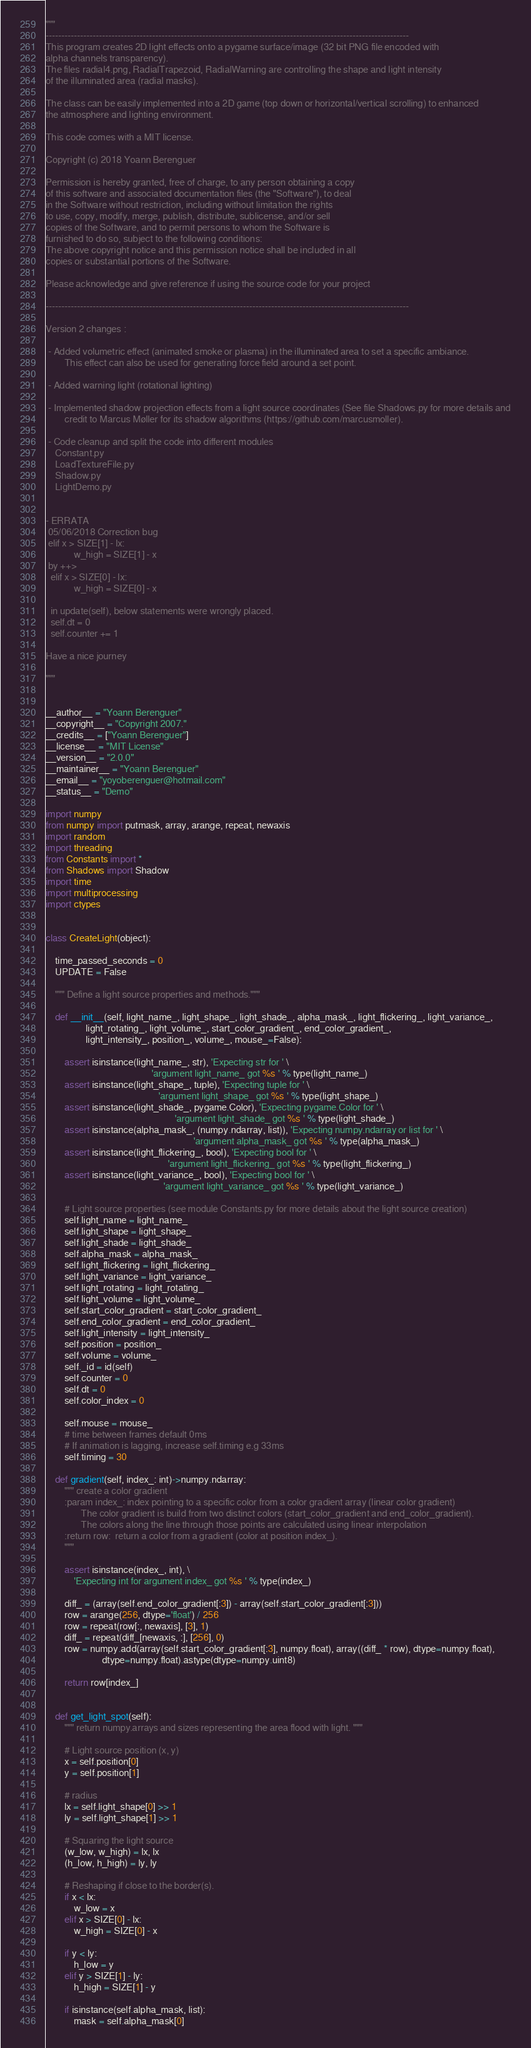<code> <loc_0><loc_0><loc_500><loc_500><_Cython_>"""
--------------------------------------------------------------------------------------------------------------------
This program creates 2D light effects onto a pygame surface/image (32 bit PNG file encoded with
alpha channels transparency).
The files radial4.png, RadialTrapezoid, RadialWarning are controlling the shape and light intensity
of the illuminated area (radial masks).

The class can be easily implemented into a 2D game (top down or horizontal/vertical scrolling) to enhanced
the atmosphere and lighting environment.

This code comes with a MIT license.

Copyright (c) 2018 Yoann Berenguer

Permission is hereby granted, free of charge, to any person obtaining a copy
of this software and associated documentation files (the "Software"), to deal
in the Software without restriction, including without limitation the rights
to use, copy, modify, merge, publish, distribute, sublicense, and/or sell
copies of the Software, and to permit persons to whom the Software is
furnished to do so, subject to the following conditions:
The above copyright notice and this permission notice shall be included in all
copies or substantial portions of the Software.

Please acknowledge and give reference if using the source code for your project

--------------------------------------------------------------------------------------------------------------------

Version 2 changes :

 - Added volumetric effect (animated smoke or plasma) in the illuminated area to set a specific ambiance.
        This effect can also be used for generating force field around a set point.

 - Added warning light (rotational lighting)

 - Implemented shadow projection effects from a light source coordinates (See file Shadows.py for more details and
        credit to Marcus Møller for its shadow algorithms (https://github.com/marcusmoller).

 - Code cleanup and split the code into different modules
    Constant.py
    LoadTextureFile.py
    Shadow.py
    LightDemo.py


- ERRATA
 05/06/2018 Correction bug
 elif x > SIZE[1] - lx:
            w_high = SIZE[1] - x
 by ++>
  elif x > SIZE[0] - lx:
            w_high = SIZE[0] - x

  in update(self), below statements were wrongly placed.
  self.dt = 0
  self.counter += 1

Have a nice journey

"""


__author__ = "Yoann Berenguer"
__copyright__ = "Copyright 2007."
__credits__ = ["Yoann Berenguer"]
__license__ = "MIT License"
__version__ = "2.0.0"
__maintainer__ = "Yoann Berenguer"
__email__ = "yoyoberenguer@hotmail.com"
__status__ = "Demo"

import numpy
from numpy import putmask, array, arange, repeat, newaxis
import random
import threading
from Constants import *
from Shadows import Shadow
import time
import multiprocessing
import ctypes


class CreateLight(object):

    time_passed_seconds = 0
    UPDATE = False

    """ Define a light source properties and methods."""

    def __init__(self, light_name_, light_shape_, light_shade_, alpha_mask_, light_flickering_, light_variance_,
                 light_rotating_, light_volume_, start_color_gradient_, end_color_gradient_,
                 light_intensity_, position_, volume_, mouse_=False):

        assert isinstance(light_name_, str), 'Expecting str for ' \
                                             'argument light_name_ got %s ' % type(light_name_)
        assert isinstance(light_shape_, tuple), 'Expecting tuple for ' \
                                                'argument light_shape_ got %s ' % type(light_shape_)
        assert isinstance(light_shade_, pygame.Color), 'Expecting pygame.Color for ' \
                                                       'argument light_shade_ got %s ' % type(light_shade_)
        assert isinstance(alpha_mask_, (numpy.ndarray, list)), 'Expecting numpy.ndarray or list for ' \
                                                               'argument alpha_mask_ got %s ' % type(alpha_mask_)
        assert isinstance(light_flickering_, bool), 'Expecting bool for ' \
                                                    'argument light_flickering_ got %s ' % type(light_flickering_)
        assert isinstance(light_variance_, bool), 'Expecting bool for ' \
                                                  'argument light_variance_ got %s ' % type(light_variance_)

        # Light source properties (see module Constants.py for more details about the light source creation)
        self.light_name = light_name_
        self.light_shape = light_shape_
        self.light_shade = light_shade_
        self.alpha_mask = alpha_mask_
        self.light_flickering = light_flickering_
        self.light_variance = light_variance_
        self.light_rotating = light_rotating_
        self.light_volume = light_volume_
        self.start_color_gradient = start_color_gradient_
        self.end_color_gradient = end_color_gradient_
        self.light_intensity = light_intensity_
        self.position = position_
        self.volume = volume_
        self._id = id(self)
        self.counter = 0
        self.dt = 0
        self.color_index = 0

        self.mouse = mouse_
        # time between frames default 0ms
        # If animation is lagging, increase self.timing e.g 33ms
        self.timing = 30

    def gradient(self, index_: int)->numpy.ndarray:
        """ create a color gradient
        :param index_: index pointing to a specific color from a color gradient array (linear color gradient)
               The color gradient is build from two distinct colors (start_color_gradient and end_color_gradient).
               The colors along the line through those points are calculated using linear interpolation
        :return row:  return a color from a gradient (color at position index_).
        """

        assert isinstance(index_, int), \
            'Expecting int for argument index_ got %s ' % type(index_)

        diff_ = (array(self.end_color_gradient[:3]) - array(self.start_color_gradient[:3]))
        row = arange(256, dtype='float') / 256
        row = repeat(row[:, newaxis], [3], 1)
        diff_ = repeat(diff_[newaxis, :], [256], 0)
        row = numpy.add(array(self.start_color_gradient[:3], numpy.float), array((diff_ * row), dtype=numpy.float),
                        dtype=numpy.float).astype(dtype=numpy.uint8)

        return row[index_]


    def get_light_spot(self):
        """ return numpy.arrays and sizes representing the area flood with light. """

        # Light source position (x, y)
        x = self.position[0]
        y = self.position[1]

        # radius
        lx = self.light_shape[0] >> 1
        ly = self.light_shape[1] >> 1

        # Squaring the light source
        (w_low, w_high) = lx, lx
        (h_low, h_high) = ly, ly

        # Reshaping if close to the border(s).
        if x < lx:
            w_low = x
        elif x > SIZE[0] - lx:
            w_high = SIZE[0] - x

        if y < ly:
            h_low = y
        elif y > SIZE[1] - ly:
            h_high = SIZE[1] - y

        if isinstance(self.alpha_mask, list):
            mask = self.alpha_mask[0]</code> 